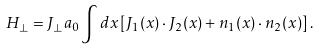Convert formula to latex. <formula><loc_0><loc_0><loc_500><loc_500>H _ { \perp } = J _ { \perp } a _ { 0 } \int d x \left [ { J } _ { 1 } ( x ) \cdot { J } _ { 2 } ( x ) + { n } _ { 1 } ( x ) \cdot { n } _ { 2 } ( x ) \right ] .</formula> 